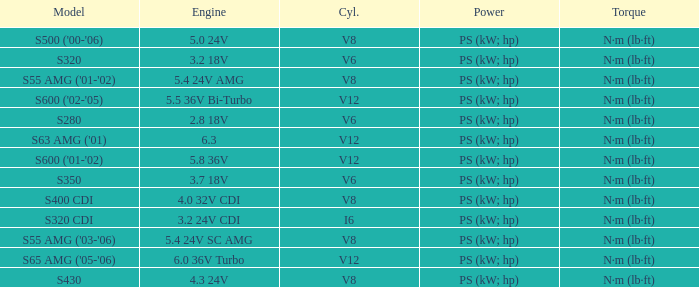Which Engine has a Model of s320 cdi? 3.2 24V CDI. 